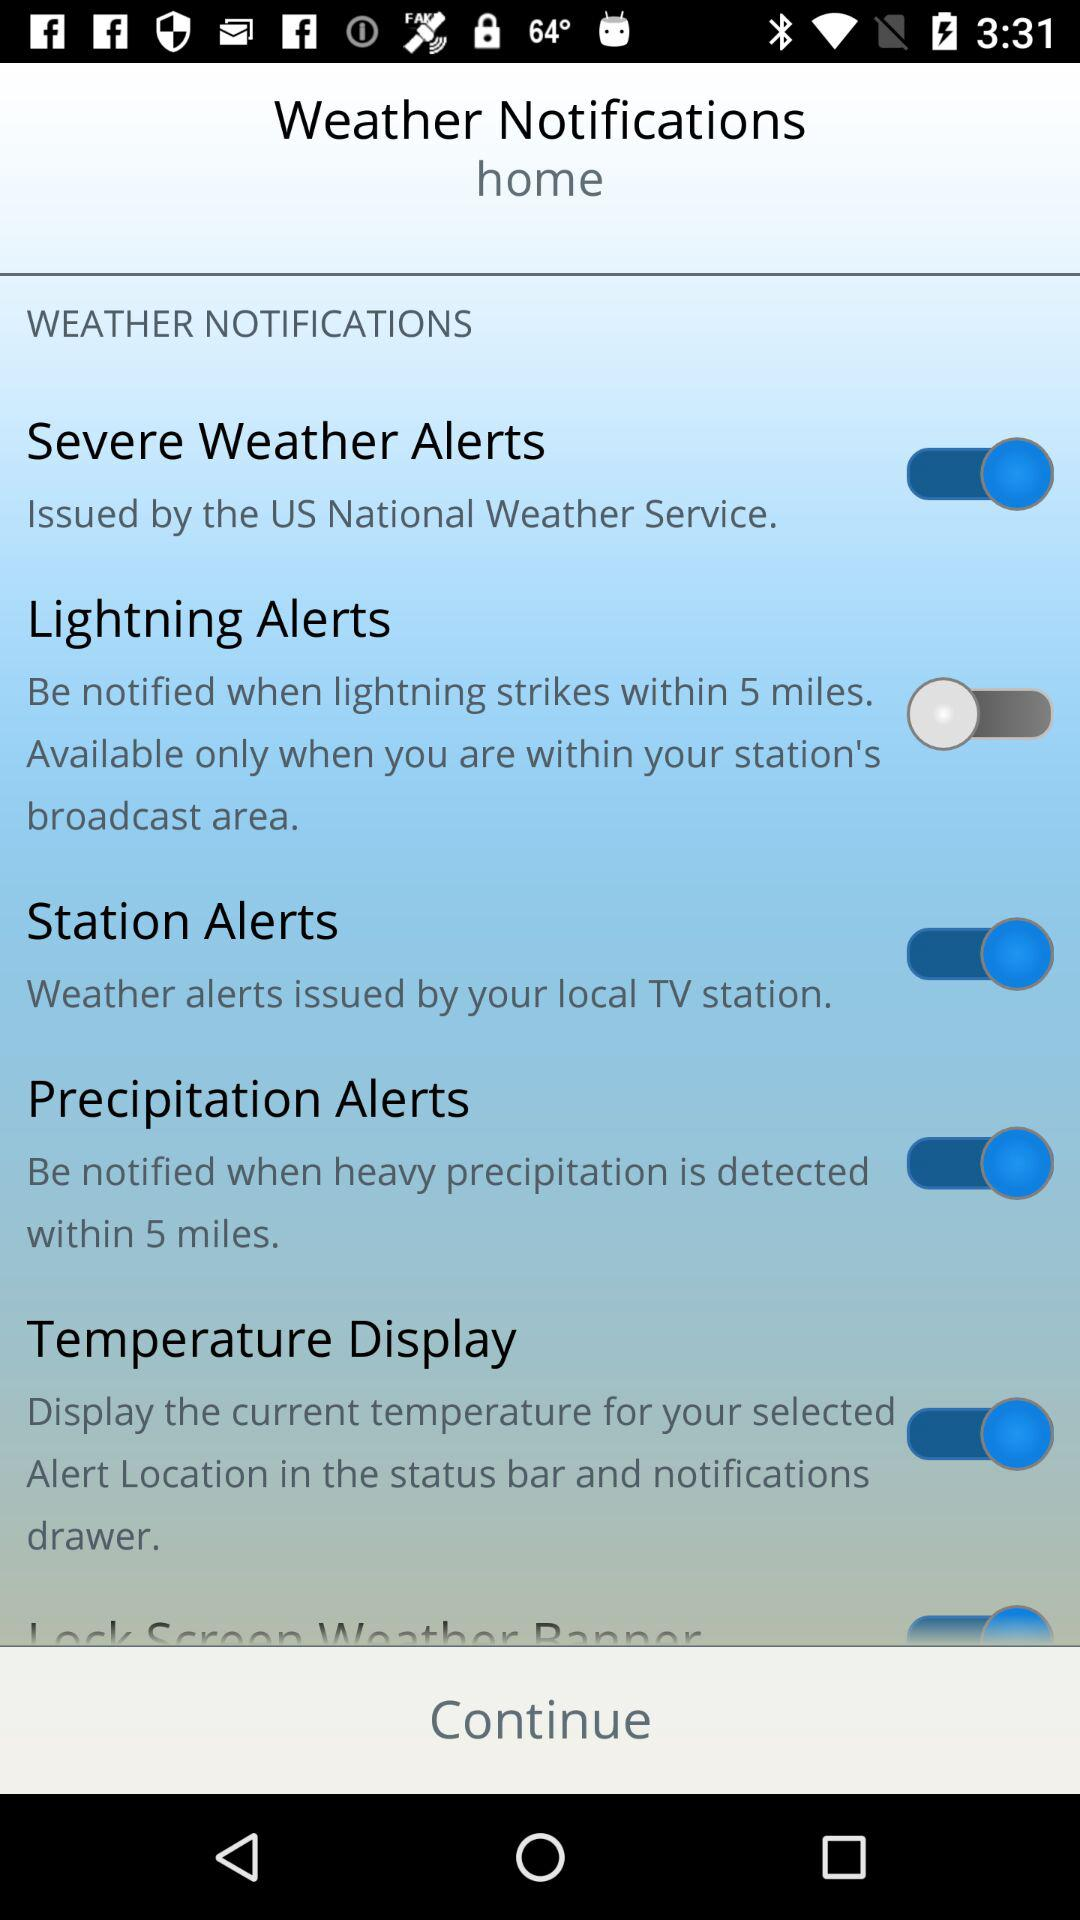What is the status of "Precipitation Alerts"? The status of "Precipitation Alerts" is "on". 